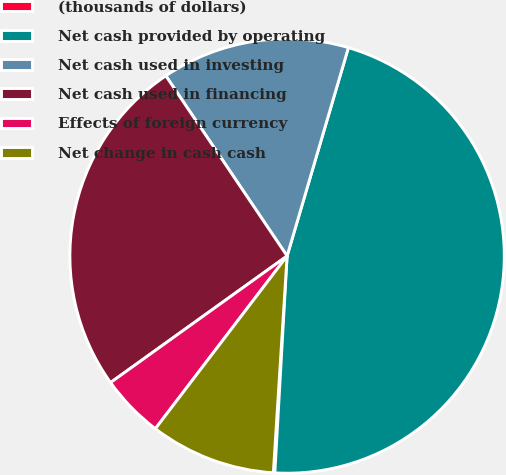<chart> <loc_0><loc_0><loc_500><loc_500><pie_chart><fcel>(thousands of dollars)<fcel>Net cash provided by operating<fcel>Net cash used in investing<fcel>Net cash used in financing<fcel>Effects of foreign currency<fcel>Net change in cash cash<nl><fcel>0.11%<fcel>46.34%<fcel>13.98%<fcel>25.47%<fcel>4.73%<fcel>9.36%<nl></chart> 